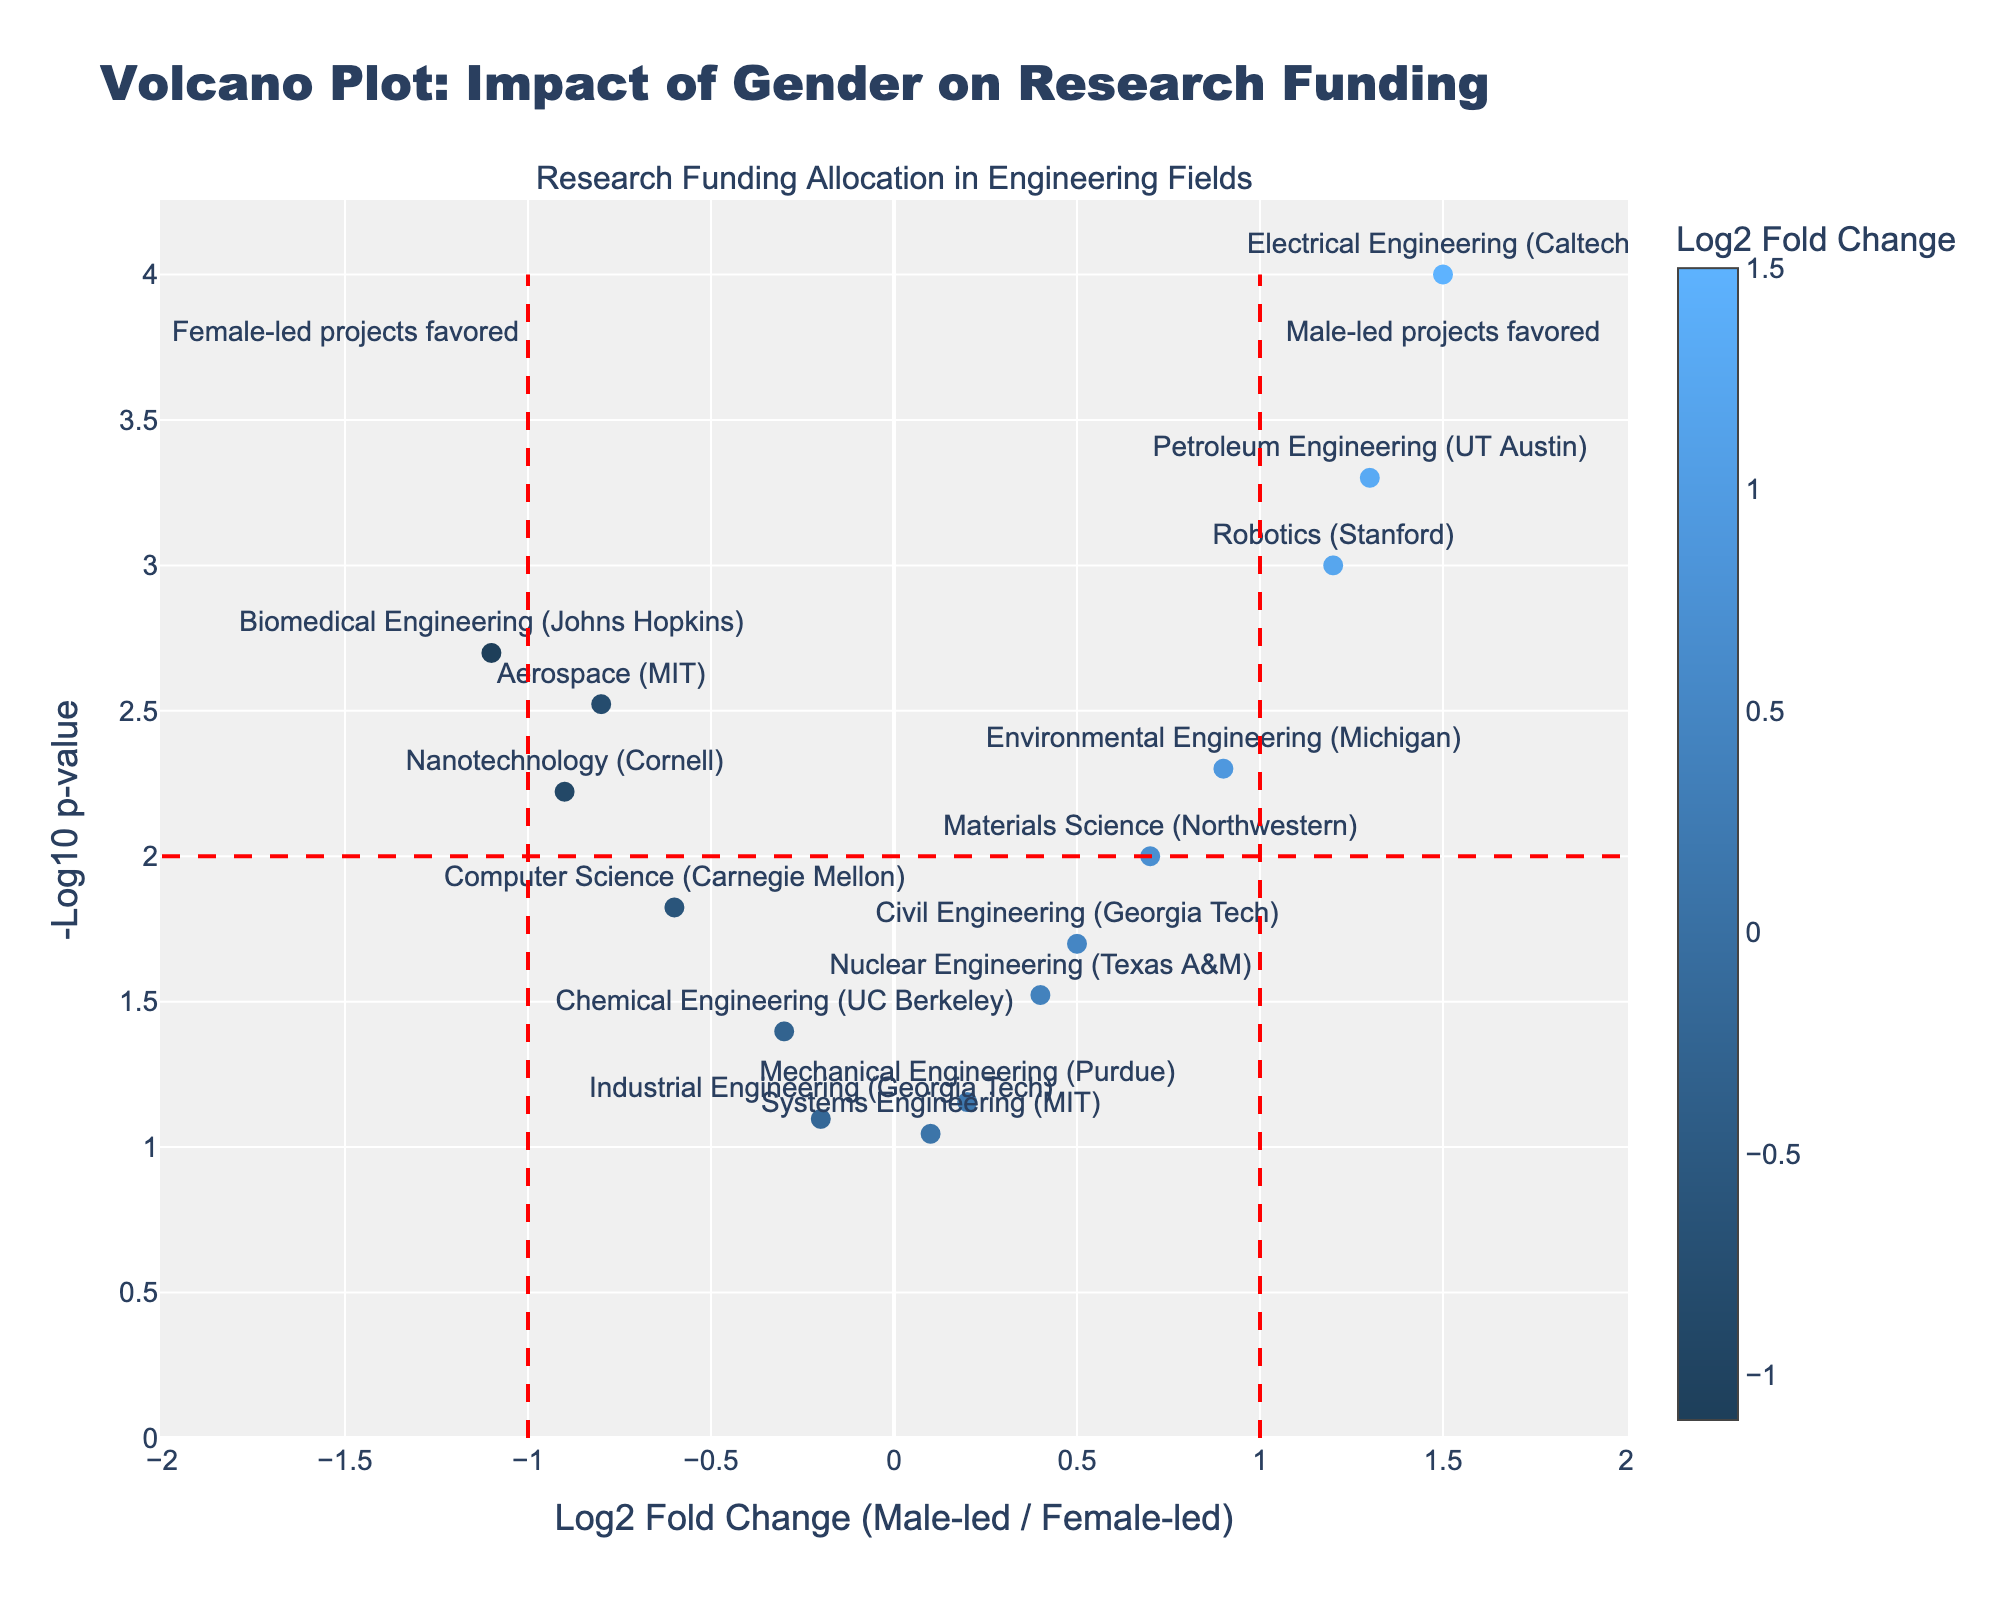How many projects are represented in the plot? To determine the number of projects, count the individual data points (markers) in the figure. Each data point corresponds to a project.
Answer: 14 Which project has the highest log2 fold change? Look for the data point that is the farthest to the right on the x-axis. The hover text might also provide specific details for better identification.
Answer: Electrical Engineering (Caltech) Which project has the lowest p-value? Examine the y-axis to find the data point that is highest, indicating the lowest p-value. The hover text might also help confirm which project it is.
Answer: Electrical Engineering (Caltech) Which projects indicate a preference for female-led projects? Look for data points located to the left of the x=0 axis. These data points represent negative log2 fold changes. The hover text can clarify further.
Answer: Aerospace (MIT), Biomedical Engineering (Johns Hopkins), Computer Science (Carnegie Mellon), Nanotechnology (Cornell), Chemical Engineering (UC Berkeley), Industrial Engineering (Georgia Tech) What does a log2 fold change value indicate in this plot? A log2 fold change value indicates the ratio of research funding between male-led and female-led projects. Positive values suggest male-led projects receive more funding, while negative values suggest female-led projects do.
Answer: Ratio of funding What can be inferred about the project 'Robotics (Stanford)' based on its position in the plot? Check the position of 'Robotics (Stanford)' in terms of its x and y coordinates; high on the y-axis indicates a significant result, while right of the y-axis indicates a preference for male-led projects.
Answer: Significant, male-led preference Identify the two projects with nearly the same fold change but different p-values. Locate two data points that are closely aligned along the x-axis but differ significantly along the y-axis. The hover text will aid in discerning their details.
Answer: Robotics (Stanford) and Petroleum Engineering (UT Austin) Which project has a significant but not large preference for male-led projects? Look for projects with statistically significant p-values (-log10(p-value) > 2) but moderate log2 fold change values close to 0 but positive.
Answer: Environmental Engineering (Michigan) How many projects show a collective non-significant result (p-value > 0.05)? Identify data points located lower on the y-axis (corresponding to -log10(p-value) < 1.301). Count these points.
Answer: 2 